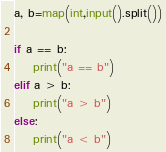<code> <loc_0><loc_0><loc_500><loc_500><_Python_>a, b=map(int,input().split())

if a == b:
    print("a == b")
elif a > b:
    print("a > b")
else:
    print("a < b")


</code> 